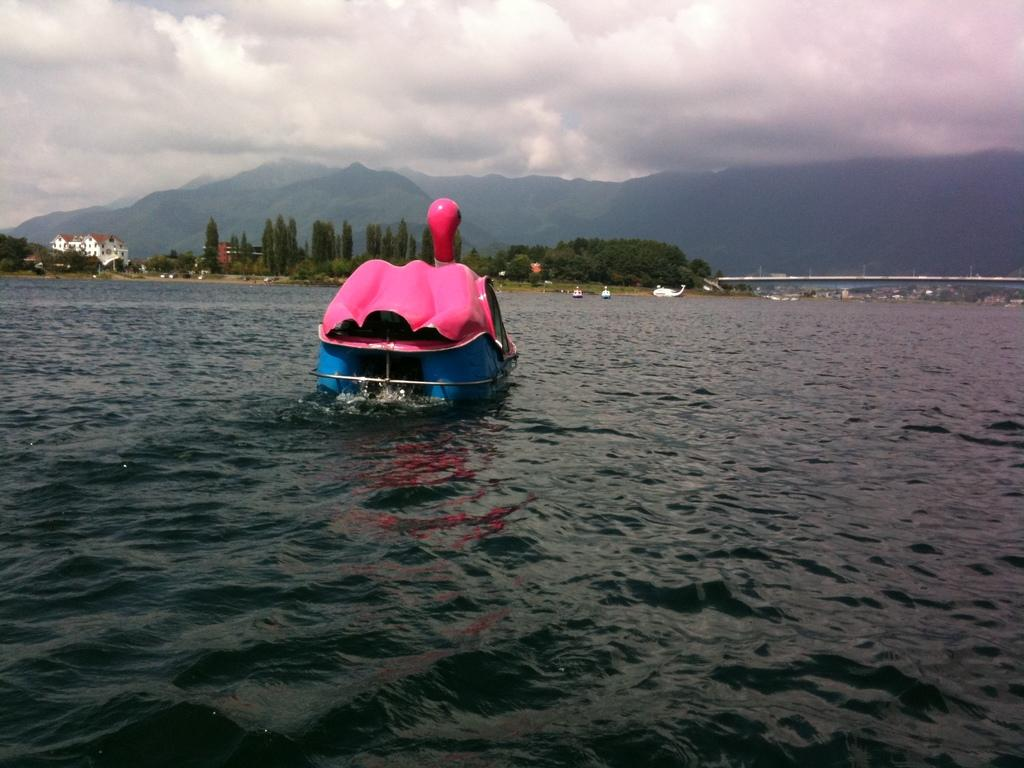What is the main subject of the image? There is an object sailing on the water surface in the image. What can be seen in the background of the image? There are trees in the background of the image. Where is the house located in the image? The house is beside the trees on the left side of the image. What type of shoe can be seen floating in the water in the image? There is no shoe present in the image; it only features an object sailing on the water surface. What emotion is the lake expressing in the image? The image does not depict a lake, and emotions cannot be attributed to inanimate objects like bodies of water. 